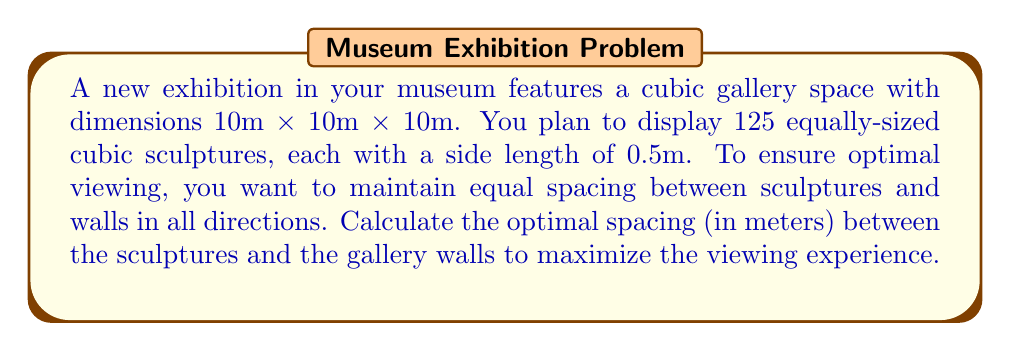Solve this math problem. Let's approach this step-by-step:

1) First, we need to determine the number of sculptures in each dimension. Since we have 125 sculptures in total, and we want them equally spaced in a cubic arrangement, we can determine that there will be 5 sculptures in each dimension (because $5^3 = 125$).

2) Now, let's define our variables:
   $x$ = spacing between sculptures and walls (and between sculptures)
   $s$ = side length of each sculpture (0.5m)

3) We can set up an equation based on the gallery dimension:
   $$10 = 5s + 6x$$
   This is because we have 5 sculptures (5s) and 6 spaces (6x) in each dimension.

4) Substituting the known value of $s$:
   $$10 = 5(0.5) + 6x$$
   $$10 = 2.5 + 6x$$

5) Solving for $x$:
   $$7.5 = 6x$$
   $$x = \frac{7.5}{6} = 1.25$$

Therefore, the optimal spacing between sculptures and walls is 1.25 meters.
Answer: 1.25 m 